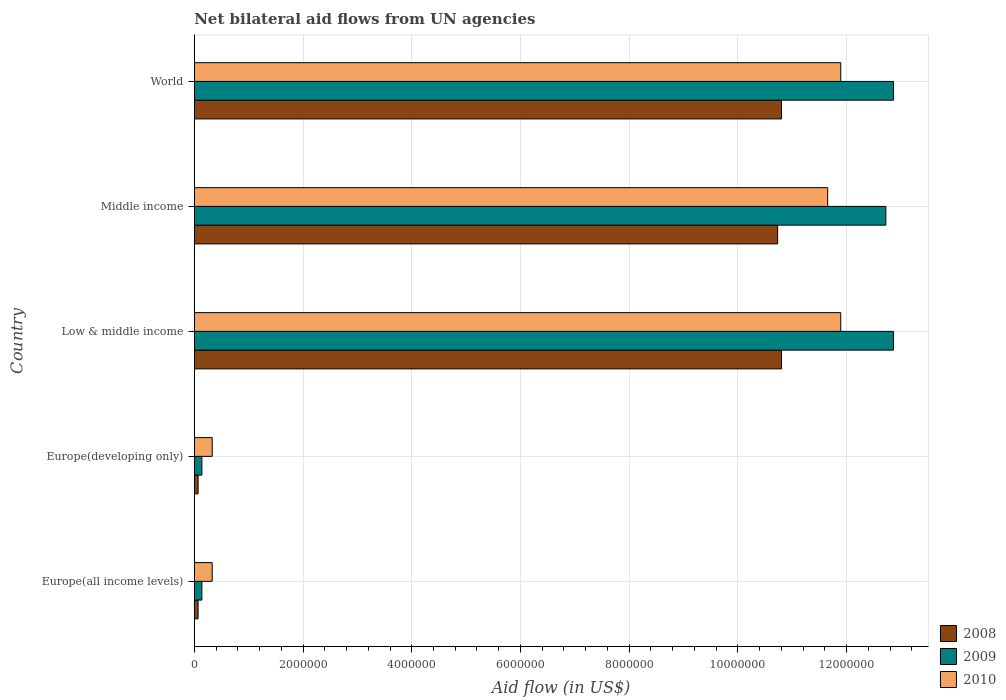How many bars are there on the 1st tick from the top?
Provide a succinct answer. 3. How many bars are there on the 2nd tick from the bottom?
Make the answer very short. 3. What is the label of the 5th group of bars from the top?
Give a very brief answer. Europe(all income levels). What is the net bilateral aid flow in 2008 in Low & middle income?
Provide a short and direct response. 1.08e+07. Across all countries, what is the maximum net bilateral aid flow in 2009?
Your answer should be compact. 1.29e+07. In which country was the net bilateral aid flow in 2008 maximum?
Provide a short and direct response. Low & middle income. In which country was the net bilateral aid flow in 2008 minimum?
Offer a terse response. Europe(all income levels). What is the total net bilateral aid flow in 2010 in the graph?
Your response must be concise. 3.61e+07. What is the difference between the net bilateral aid flow in 2010 in Europe(developing only) and the net bilateral aid flow in 2009 in Europe(all income levels)?
Keep it short and to the point. 1.90e+05. What is the average net bilateral aid flow in 2008 per country?
Give a very brief answer. 6.49e+06. What is the ratio of the net bilateral aid flow in 2008 in Europe(developing only) to that in World?
Offer a terse response. 0.01. Is the net bilateral aid flow in 2010 in Low & middle income less than that in Middle income?
Offer a terse response. No. What is the difference between the highest and the lowest net bilateral aid flow in 2009?
Provide a short and direct response. 1.27e+07. In how many countries, is the net bilateral aid flow in 2009 greater than the average net bilateral aid flow in 2009 taken over all countries?
Offer a terse response. 3. What does the 3rd bar from the top in Europe(developing only) represents?
Give a very brief answer. 2008. How many countries are there in the graph?
Ensure brevity in your answer.  5. What is the difference between two consecutive major ticks on the X-axis?
Your response must be concise. 2.00e+06. How many legend labels are there?
Offer a very short reply. 3. How are the legend labels stacked?
Make the answer very short. Vertical. What is the title of the graph?
Keep it short and to the point. Net bilateral aid flows from UN agencies. What is the label or title of the X-axis?
Keep it short and to the point. Aid flow (in US$). What is the Aid flow (in US$) of 2008 in Europe(all income levels)?
Your answer should be compact. 7.00e+04. What is the Aid flow (in US$) in 2009 in Europe(all income levels)?
Provide a short and direct response. 1.40e+05. What is the Aid flow (in US$) in 2010 in Europe(all income levels)?
Give a very brief answer. 3.30e+05. What is the Aid flow (in US$) of 2010 in Europe(developing only)?
Your answer should be very brief. 3.30e+05. What is the Aid flow (in US$) in 2008 in Low & middle income?
Provide a short and direct response. 1.08e+07. What is the Aid flow (in US$) of 2009 in Low & middle income?
Give a very brief answer. 1.29e+07. What is the Aid flow (in US$) of 2010 in Low & middle income?
Offer a terse response. 1.19e+07. What is the Aid flow (in US$) in 2008 in Middle income?
Offer a terse response. 1.07e+07. What is the Aid flow (in US$) of 2009 in Middle income?
Provide a short and direct response. 1.27e+07. What is the Aid flow (in US$) of 2010 in Middle income?
Give a very brief answer. 1.16e+07. What is the Aid flow (in US$) in 2008 in World?
Your response must be concise. 1.08e+07. What is the Aid flow (in US$) of 2009 in World?
Your answer should be very brief. 1.29e+07. What is the Aid flow (in US$) in 2010 in World?
Your answer should be very brief. 1.19e+07. Across all countries, what is the maximum Aid flow (in US$) in 2008?
Provide a short and direct response. 1.08e+07. Across all countries, what is the maximum Aid flow (in US$) in 2009?
Your answer should be compact. 1.29e+07. Across all countries, what is the maximum Aid flow (in US$) of 2010?
Make the answer very short. 1.19e+07. Across all countries, what is the minimum Aid flow (in US$) of 2009?
Provide a succinct answer. 1.40e+05. What is the total Aid flow (in US$) in 2008 in the graph?
Keep it short and to the point. 3.25e+07. What is the total Aid flow (in US$) of 2009 in the graph?
Your answer should be compact. 3.87e+07. What is the total Aid flow (in US$) in 2010 in the graph?
Provide a succinct answer. 3.61e+07. What is the difference between the Aid flow (in US$) in 2008 in Europe(all income levels) and that in Europe(developing only)?
Offer a very short reply. 0. What is the difference between the Aid flow (in US$) in 2009 in Europe(all income levels) and that in Europe(developing only)?
Your response must be concise. 0. What is the difference between the Aid flow (in US$) of 2010 in Europe(all income levels) and that in Europe(developing only)?
Your answer should be very brief. 0. What is the difference between the Aid flow (in US$) in 2008 in Europe(all income levels) and that in Low & middle income?
Keep it short and to the point. -1.07e+07. What is the difference between the Aid flow (in US$) in 2009 in Europe(all income levels) and that in Low & middle income?
Provide a succinct answer. -1.27e+07. What is the difference between the Aid flow (in US$) in 2010 in Europe(all income levels) and that in Low & middle income?
Keep it short and to the point. -1.16e+07. What is the difference between the Aid flow (in US$) of 2008 in Europe(all income levels) and that in Middle income?
Keep it short and to the point. -1.07e+07. What is the difference between the Aid flow (in US$) of 2009 in Europe(all income levels) and that in Middle income?
Give a very brief answer. -1.26e+07. What is the difference between the Aid flow (in US$) of 2010 in Europe(all income levels) and that in Middle income?
Keep it short and to the point. -1.13e+07. What is the difference between the Aid flow (in US$) in 2008 in Europe(all income levels) and that in World?
Your answer should be compact. -1.07e+07. What is the difference between the Aid flow (in US$) of 2009 in Europe(all income levels) and that in World?
Your response must be concise. -1.27e+07. What is the difference between the Aid flow (in US$) of 2010 in Europe(all income levels) and that in World?
Give a very brief answer. -1.16e+07. What is the difference between the Aid flow (in US$) in 2008 in Europe(developing only) and that in Low & middle income?
Your answer should be very brief. -1.07e+07. What is the difference between the Aid flow (in US$) of 2009 in Europe(developing only) and that in Low & middle income?
Make the answer very short. -1.27e+07. What is the difference between the Aid flow (in US$) of 2010 in Europe(developing only) and that in Low & middle income?
Make the answer very short. -1.16e+07. What is the difference between the Aid flow (in US$) in 2008 in Europe(developing only) and that in Middle income?
Offer a very short reply. -1.07e+07. What is the difference between the Aid flow (in US$) in 2009 in Europe(developing only) and that in Middle income?
Give a very brief answer. -1.26e+07. What is the difference between the Aid flow (in US$) in 2010 in Europe(developing only) and that in Middle income?
Give a very brief answer. -1.13e+07. What is the difference between the Aid flow (in US$) in 2008 in Europe(developing only) and that in World?
Your answer should be compact. -1.07e+07. What is the difference between the Aid flow (in US$) in 2009 in Europe(developing only) and that in World?
Keep it short and to the point. -1.27e+07. What is the difference between the Aid flow (in US$) in 2010 in Europe(developing only) and that in World?
Your response must be concise. -1.16e+07. What is the difference between the Aid flow (in US$) of 2008 in Low & middle income and that in Middle income?
Offer a very short reply. 7.00e+04. What is the difference between the Aid flow (in US$) in 2010 in Low & middle income and that in Middle income?
Provide a succinct answer. 2.40e+05. What is the difference between the Aid flow (in US$) in 2008 in Low & middle income and that in World?
Offer a terse response. 0. What is the difference between the Aid flow (in US$) of 2010 in Middle income and that in World?
Your answer should be very brief. -2.40e+05. What is the difference between the Aid flow (in US$) of 2008 in Europe(all income levels) and the Aid flow (in US$) of 2009 in Europe(developing only)?
Your response must be concise. -7.00e+04. What is the difference between the Aid flow (in US$) of 2008 in Europe(all income levels) and the Aid flow (in US$) of 2010 in Europe(developing only)?
Your response must be concise. -2.60e+05. What is the difference between the Aid flow (in US$) in 2008 in Europe(all income levels) and the Aid flow (in US$) in 2009 in Low & middle income?
Your response must be concise. -1.28e+07. What is the difference between the Aid flow (in US$) in 2008 in Europe(all income levels) and the Aid flow (in US$) in 2010 in Low & middle income?
Offer a very short reply. -1.18e+07. What is the difference between the Aid flow (in US$) of 2009 in Europe(all income levels) and the Aid flow (in US$) of 2010 in Low & middle income?
Your answer should be compact. -1.18e+07. What is the difference between the Aid flow (in US$) of 2008 in Europe(all income levels) and the Aid flow (in US$) of 2009 in Middle income?
Provide a short and direct response. -1.26e+07. What is the difference between the Aid flow (in US$) of 2008 in Europe(all income levels) and the Aid flow (in US$) of 2010 in Middle income?
Offer a very short reply. -1.16e+07. What is the difference between the Aid flow (in US$) in 2009 in Europe(all income levels) and the Aid flow (in US$) in 2010 in Middle income?
Give a very brief answer. -1.15e+07. What is the difference between the Aid flow (in US$) of 2008 in Europe(all income levels) and the Aid flow (in US$) of 2009 in World?
Provide a short and direct response. -1.28e+07. What is the difference between the Aid flow (in US$) in 2008 in Europe(all income levels) and the Aid flow (in US$) in 2010 in World?
Your answer should be very brief. -1.18e+07. What is the difference between the Aid flow (in US$) in 2009 in Europe(all income levels) and the Aid flow (in US$) in 2010 in World?
Your answer should be very brief. -1.18e+07. What is the difference between the Aid flow (in US$) in 2008 in Europe(developing only) and the Aid flow (in US$) in 2009 in Low & middle income?
Offer a very short reply. -1.28e+07. What is the difference between the Aid flow (in US$) in 2008 in Europe(developing only) and the Aid flow (in US$) in 2010 in Low & middle income?
Your answer should be very brief. -1.18e+07. What is the difference between the Aid flow (in US$) of 2009 in Europe(developing only) and the Aid flow (in US$) of 2010 in Low & middle income?
Offer a terse response. -1.18e+07. What is the difference between the Aid flow (in US$) in 2008 in Europe(developing only) and the Aid flow (in US$) in 2009 in Middle income?
Ensure brevity in your answer.  -1.26e+07. What is the difference between the Aid flow (in US$) of 2008 in Europe(developing only) and the Aid flow (in US$) of 2010 in Middle income?
Your answer should be very brief. -1.16e+07. What is the difference between the Aid flow (in US$) in 2009 in Europe(developing only) and the Aid flow (in US$) in 2010 in Middle income?
Provide a short and direct response. -1.15e+07. What is the difference between the Aid flow (in US$) in 2008 in Europe(developing only) and the Aid flow (in US$) in 2009 in World?
Your answer should be compact. -1.28e+07. What is the difference between the Aid flow (in US$) in 2008 in Europe(developing only) and the Aid flow (in US$) in 2010 in World?
Your answer should be very brief. -1.18e+07. What is the difference between the Aid flow (in US$) in 2009 in Europe(developing only) and the Aid flow (in US$) in 2010 in World?
Your answer should be compact. -1.18e+07. What is the difference between the Aid flow (in US$) in 2008 in Low & middle income and the Aid flow (in US$) in 2009 in Middle income?
Your response must be concise. -1.92e+06. What is the difference between the Aid flow (in US$) in 2008 in Low & middle income and the Aid flow (in US$) in 2010 in Middle income?
Ensure brevity in your answer.  -8.50e+05. What is the difference between the Aid flow (in US$) in 2009 in Low & middle income and the Aid flow (in US$) in 2010 in Middle income?
Offer a terse response. 1.21e+06. What is the difference between the Aid flow (in US$) of 2008 in Low & middle income and the Aid flow (in US$) of 2009 in World?
Your response must be concise. -2.06e+06. What is the difference between the Aid flow (in US$) of 2008 in Low & middle income and the Aid flow (in US$) of 2010 in World?
Provide a succinct answer. -1.09e+06. What is the difference between the Aid flow (in US$) in 2009 in Low & middle income and the Aid flow (in US$) in 2010 in World?
Offer a terse response. 9.70e+05. What is the difference between the Aid flow (in US$) in 2008 in Middle income and the Aid flow (in US$) in 2009 in World?
Provide a succinct answer. -2.13e+06. What is the difference between the Aid flow (in US$) in 2008 in Middle income and the Aid flow (in US$) in 2010 in World?
Give a very brief answer. -1.16e+06. What is the difference between the Aid flow (in US$) of 2009 in Middle income and the Aid flow (in US$) of 2010 in World?
Offer a terse response. 8.30e+05. What is the average Aid flow (in US$) in 2008 per country?
Provide a succinct answer. 6.49e+06. What is the average Aid flow (in US$) of 2009 per country?
Ensure brevity in your answer.  7.74e+06. What is the average Aid flow (in US$) of 2010 per country?
Ensure brevity in your answer.  7.22e+06. What is the difference between the Aid flow (in US$) of 2008 and Aid flow (in US$) of 2010 in Europe(all income levels)?
Your response must be concise. -2.60e+05. What is the difference between the Aid flow (in US$) in 2009 and Aid flow (in US$) in 2010 in Europe(all income levels)?
Make the answer very short. -1.90e+05. What is the difference between the Aid flow (in US$) of 2008 and Aid flow (in US$) of 2009 in Europe(developing only)?
Your answer should be compact. -7.00e+04. What is the difference between the Aid flow (in US$) in 2008 and Aid flow (in US$) in 2009 in Low & middle income?
Your response must be concise. -2.06e+06. What is the difference between the Aid flow (in US$) in 2008 and Aid flow (in US$) in 2010 in Low & middle income?
Offer a terse response. -1.09e+06. What is the difference between the Aid flow (in US$) in 2009 and Aid flow (in US$) in 2010 in Low & middle income?
Keep it short and to the point. 9.70e+05. What is the difference between the Aid flow (in US$) in 2008 and Aid flow (in US$) in 2009 in Middle income?
Provide a short and direct response. -1.99e+06. What is the difference between the Aid flow (in US$) of 2008 and Aid flow (in US$) of 2010 in Middle income?
Give a very brief answer. -9.20e+05. What is the difference between the Aid flow (in US$) of 2009 and Aid flow (in US$) of 2010 in Middle income?
Make the answer very short. 1.07e+06. What is the difference between the Aid flow (in US$) in 2008 and Aid flow (in US$) in 2009 in World?
Provide a short and direct response. -2.06e+06. What is the difference between the Aid flow (in US$) in 2008 and Aid flow (in US$) in 2010 in World?
Give a very brief answer. -1.09e+06. What is the difference between the Aid flow (in US$) of 2009 and Aid flow (in US$) of 2010 in World?
Keep it short and to the point. 9.70e+05. What is the ratio of the Aid flow (in US$) in 2010 in Europe(all income levels) to that in Europe(developing only)?
Provide a succinct answer. 1. What is the ratio of the Aid flow (in US$) in 2008 in Europe(all income levels) to that in Low & middle income?
Your answer should be compact. 0.01. What is the ratio of the Aid flow (in US$) of 2009 in Europe(all income levels) to that in Low & middle income?
Give a very brief answer. 0.01. What is the ratio of the Aid flow (in US$) of 2010 in Europe(all income levels) to that in Low & middle income?
Give a very brief answer. 0.03. What is the ratio of the Aid flow (in US$) of 2008 in Europe(all income levels) to that in Middle income?
Your answer should be compact. 0.01. What is the ratio of the Aid flow (in US$) in 2009 in Europe(all income levels) to that in Middle income?
Provide a short and direct response. 0.01. What is the ratio of the Aid flow (in US$) of 2010 in Europe(all income levels) to that in Middle income?
Keep it short and to the point. 0.03. What is the ratio of the Aid flow (in US$) in 2008 in Europe(all income levels) to that in World?
Provide a short and direct response. 0.01. What is the ratio of the Aid flow (in US$) in 2009 in Europe(all income levels) to that in World?
Provide a short and direct response. 0.01. What is the ratio of the Aid flow (in US$) of 2010 in Europe(all income levels) to that in World?
Provide a short and direct response. 0.03. What is the ratio of the Aid flow (in US$) of 2008 in Europe(developing only) to that in Low & middle income?
Your answer should be very brief. 0.01. What is the ratio of the Aid flow (in US$) of 2009 in Europe(developing only) to that in Low & middle income?
Your answer should be very brief. 0.01. What is the ratio of the Aid flow (in US$) of 2010 in Europe(developing only) to that in Low & middle income?
Give a very brief answer. 0.03. What is the ratio of the Aid flow (in US$) of 2008 in Europe(developing only) to that in Middle income?
Your answer should be compact. 0.01. What is the ratio of the Aid flow (in US$) of 2009 in Europe(developing only) to that in Middle income?
Ensure brevity in your answer.  0.01. What is the ratio of the Aid flow (in US$) in 2010 in Europe(developing only) to that in Middle income?
Offer a very short reply. 0.03. What is the ratio of the Aid flow (in US$) in 2008 in Europe(developing only) to that in World?
Give a very brief answer. 0.01. What is the ratio of the Aid flow (in US$) in 2009 in Europe(developing only) to that in World?
Your response must be concise. 0.01. What is the ratio of the Aid flow (in US$) of 2010 in Europe(developing only) to that in World?
Make the answer very short. 0.03. What is the ratio of the Aid flow (in US$) in 2009 in Low & middle income to that in Middle income?
Make the answer very short. 1.01. What is the ratio of the Aid flow (in US$) in 2010 in Low & middle income to that in Middle income?
Offer a very short reply. 1.02. What is the ratio of the Aid flow (in US$) of 2009 in Low & middle income to that in World?
Make the answer very short. 1. What is the ratio of the Aid flow (in US$) in 2010 in Low & middle income to that in World?
Make the answer very short. 1. What is the ratio of the Aid flow (in US$) of 2008 in Middle income to that in World?
Give a very brief answer. 0.99. What is the ratio of the Aid flow (in US$) of 2010 in Middle income to that in World?
Provide a short and direct response. 0.98. What is the difference between the highest and the second highest Aid flow (in US$) in 2010?
Provide a succinct answer. 0. What is the difference between the highest and the lowest Aid flow (in US$) in 2008?
Make the answer very short. 1.07e+07. What is the difference between the highest and the lowest Aid flow (in US$) in 2009?
Your answer should be very brief. 1.27e+07. What is the difference between the highest and the lowest Aid flow (in US$) of 2010?
Provide a short and direct response. 1.16e+07. 